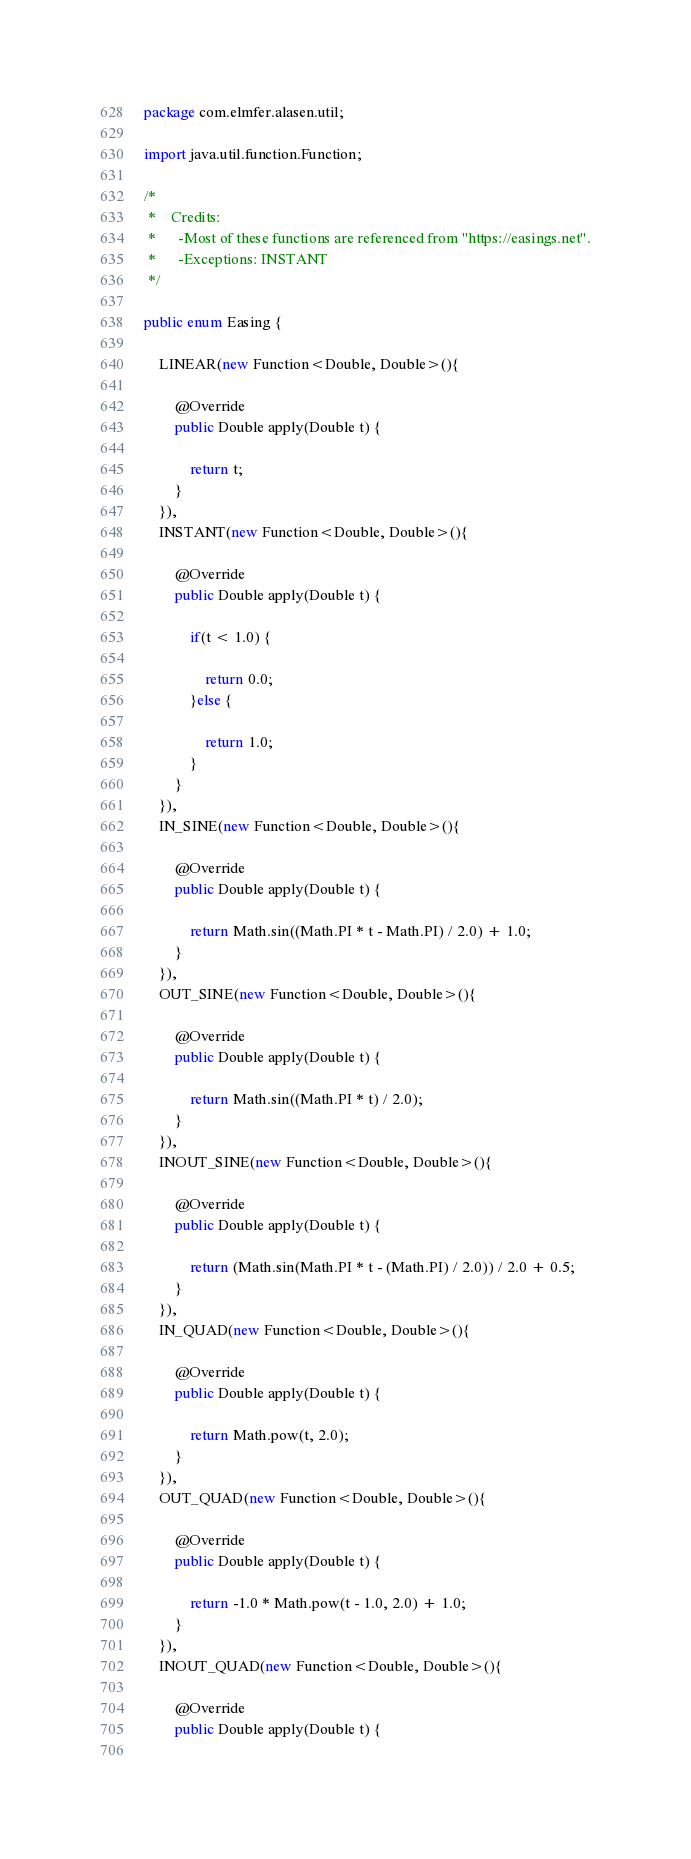<code> <loc_0><loc_0><loc_500><loc_500><_Java_>package com.elmfer.alasen.util;

import java.util.function.Function;

/*
 *    Credits:
 *    	-Most of these functions are referenced from "https://easings.net".
 *    	-Exceptions: INSTANT
 */

public enum Easing {
	
	LINEAR(new Function<Double, Double>(){
		
		@Override
		public Double apply(Double t) {
			
			return t;
		}
	}),
	INSTANT(new Function<Double, Double>(){

		@Override
		public Double apply(Double t) {
			
			if(t < 1.0) {
				
				return 0.0;
			}else {
				
				return 1.0;
			}
		}
	}),
	IN_SINE(new Function<Double, Double>(){

		@Override
		public Double apply(Double t) {
			
			return Math.sin((Math.PI * t - Math.PI) / 2.0) + 1.0;
		}
	}),
	OUT_SINE(new Function<Double, Double>(){

		@Override
		public Double apply(Double t) {
			
			return Math.sin((Math.PI * t) / 2.0);
		}
	}),
	INOUT_SINE(new Function<Double, Double>(){

		@Override
		public Double apply(Double t) {
			
			return (Math.sin(Math.PI * t - (Math.PI) / 2.0)) / 2.0 + 0.5;
		}
	}),
	IN_QUAD(new Function<Double, Double>(){

		@Override
		public Double apply(Double t) {
			
			return Math.pow(t, 2.0);
		}
	}),
	OUT_QUAD(new Function<Double, Double>(){

		@Override
		public Double apply(Double t) {
			
			return -1.0 * Math.pow(t - 1.0, 2.0) + 1.0;
		}
	}),
	INOUT_QUAD(new Function<Double, Double>(){

		@Override
		public Double apply(Double t) {
			</code> 